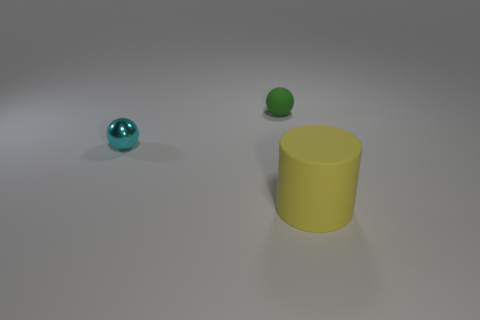Add 2 brown things. How many objects exist? 5 Subtract all cylinders. How many objects are left? 2 Add 1 gray rubber cylinders. How many gray rubber cylinders exist? 1 Subtract 0 brown cylinders. How many objects are left? 3 Subtract all small matte spheres. Subtract all big matte cylinders. How many objects are left? 1 Add 2 small cyan metal things. How many small cyan metal things are left? 3 